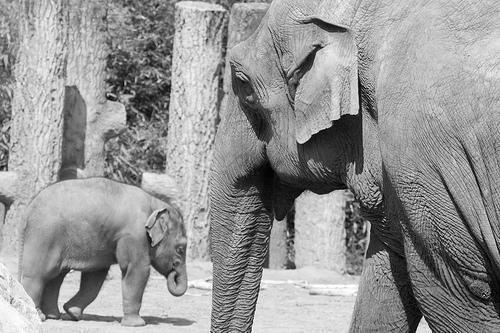How many elephants are there?
Give a very brief answer. 2. 